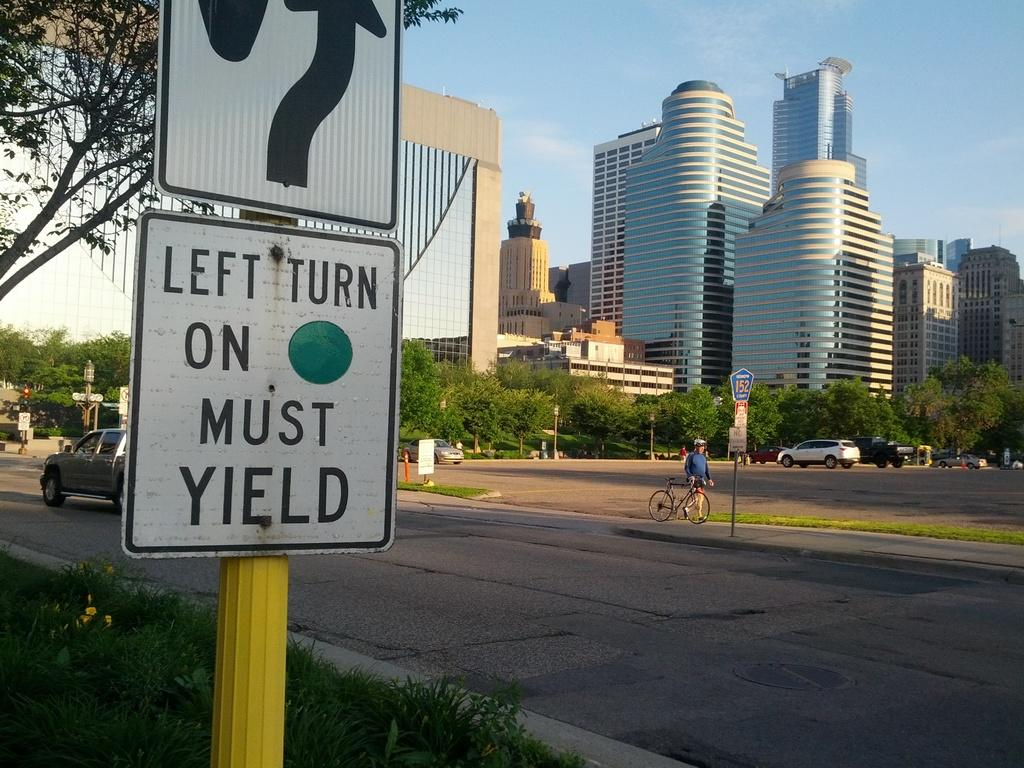Provide a one-sentence caption for the provided image. A road sign tells motorists to yield at the left turn. 